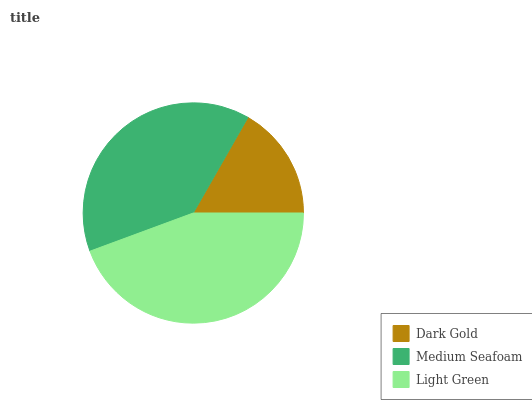Is Dark Gold the minimum?
Answer yes or no. Yes. Is Light Green the maximum?
Answer yes or no. Yes. Is Medium Seafoam the minimum?
Answer yes or no. No. Is Medium Seafoam the maximum?
Answer yes or no. No. Is Medium Seafoam greater than Dark Gold?
Answer yes or no. Yes. Is Dark Gold less than Medium Seafoam?
Answer yes or no. Yes. Is Dark Gold greater than Medium Seafoam?
Answer yes or no. No. Is Medium Seafoam less than Dark Gold?
Answer yes or no. No. Is Medium Seafoam the high median?
Answer yes or no. Yes. Is Medium Seafoam the low median?
Answer yes or no. Yes. Is Light Green the high median?
Answer yes or no. No. Is Light Green the low median?
Answer yes or no. No. 